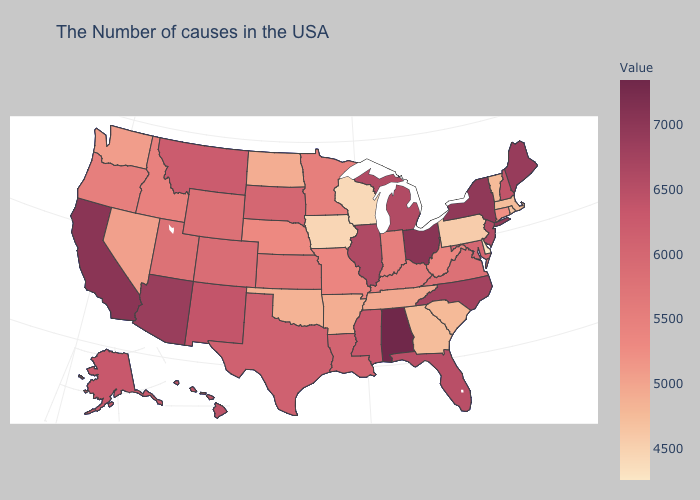Which states have the lowest value in the USA?
Be succinct. Delaware. Which states have the highest value in the USA?
Answer briefly. Alabama. Does Colorado have the lowest value in the West?
Be succinct. No. Which states have the lowest value in the USA?
Write a very short answer. Delaware. Does Ohio have a lower value than Nebraska?
Give a very brief answer. No. 